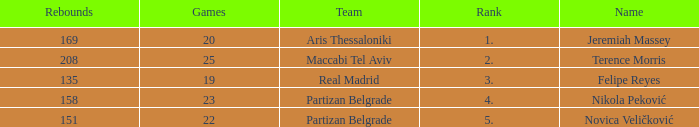What is the number of Games for the Maccabi Tel Aviv Team with less than 208 Rebounds? None. 